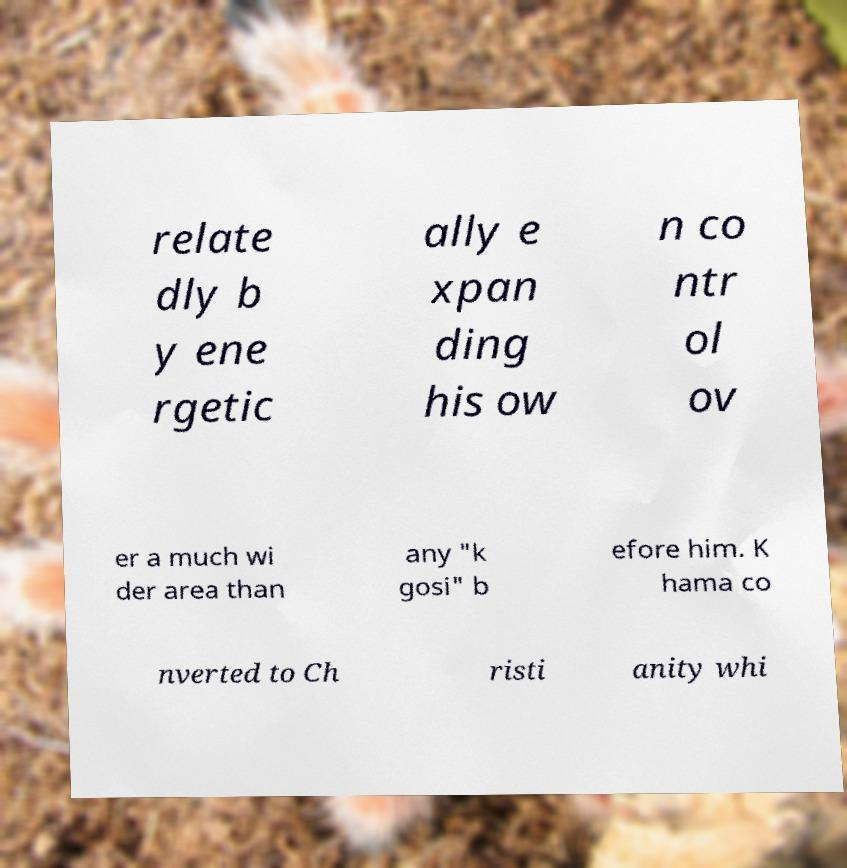Please read and relay the text visible in this image. What does it say? relate dly b y ene rgetic ally e xpan ding his ow n co ntr ol ov er a much wi der area than any "k gosi" b efore him. K hama co nverted to Ch risti anity whi 